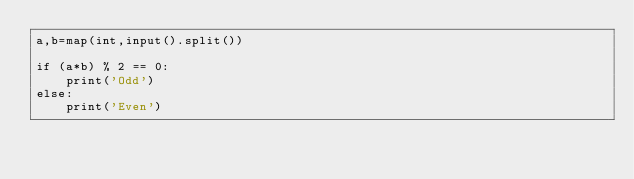<code> <loc_0><loc_0><loc_500><loc_500><_Python_>a,b=map(int,input().split())

if (a*b) % 2 == 0:
	print('Odd')
else:
	print('Even')
</code> 